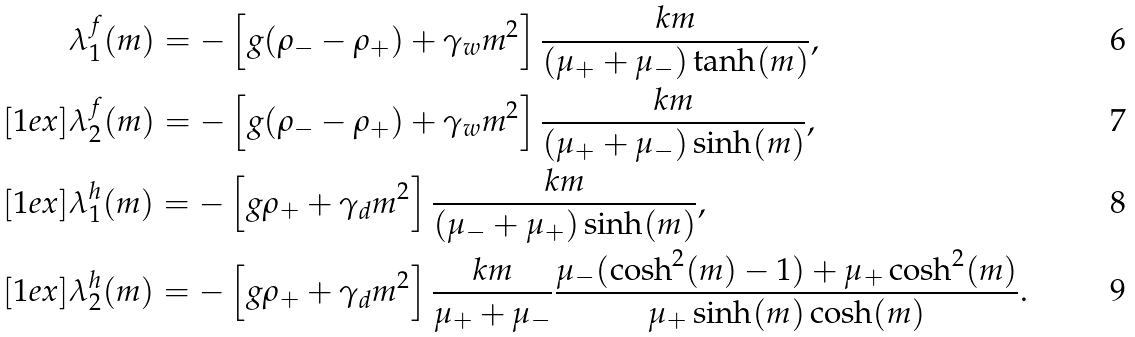Convert formula to latex. <formula><loc_0><loc_0><loc_500><loc_500>& \lambda ^ { f } _ { 1 } ( m ) = - \left [ g ( \rho _ { - } - \rho _ { + } ) + \gamma _ { w } m ^ { 2 } \right ] \frac { k m } { ( \mu _ { + } + \mu _ { - } ) \tanh ( m ) } , \\ [ 1 e x ] & \lambda ^ { f } _ { 2 } ( m ) = - \left [ g ( \rho _ { - } - \rho _ { + } ) + \gamma _ { w } m ^ { 2 } \right ] \frac { k m } { ( \mu _ { + } + \mu _ { - } ) \sinh ( m ) } , \\ [ 1 e x ] & \lambda ^ { h } _ { 1 } ( m ) = - \left [ g \rho _ { + } + \gamma _ { d } m ^ { 2 } \right ] \frac { k m } { ( \mu _ { - } + \mu _ { + } ) \sinh ( m ) } , \\ [ 1 e x ] & \lambda ^ { h } _ { 2 } ( m ) = - \left [ g \rho _ { + } + \gamma _ { d } m ^ { 2 } \right ] \frac { k m } { \mu _ { + } + \mu _ { - } } \frac { \mu _ { - } ( \cosh ^ { 2 } ( m ) - 1 ) + \mu _ { + } \cosh ^ { 2 } ( m ) } { \mu _ { + } \sinh ( m ) \cosh ( m ) } .</formula> 